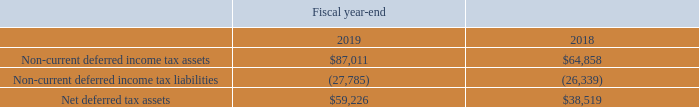The net deferred tax asset is classified on the consolidated balance sheets as follows (in thousands):
We have various tax attribute carryforwards which include the following:
• Foreign federal and local gross net operating loss carryforwards are $61.6 million, of which $47.0 million have no expiration date and $14.6 million have various expiration dates beginning in fiscal 2020. Among the total of $61.6 million foreign net operating loss carryforwards, a valuation allowance of $31.7 million has been provided for certain jurisdictions since the recovery of the carryforwards is uncertain. U.S. federal and certain state gross net operating loss carryforwards are $14.0 million and $30.7 million, respectively, which were acquired from our acquisitions. A full valuation allowance against certain other state net operating losses of $30.7 million has been recorded. California gross net operating loss carryforwards are $2.8 million and are scheduled to expire beginning in fiscal 2032.
• U.S. federal R&D credit carryforwards of $35.4 million are scheduled to expire beginning in fiscal 2025. California R&D credit carryforwards of $32.2 million have no expiration date. A total of $27.1 million valuation allowance, before U.S. federal benefit, has been recorded against California R&D credit carryforwards of $32.2 million since the recovery of the carryforwards is uncertain. Other states R&D credit carryforwards of $3.9 million are scheduled to expire beginning in fiscal 2020. A valuation allowance totaling $2.7 million, before U.S. federal benefit, has been recorded against certain state R&D credit carryforwards of $3.9 million since the recovery of the carryforwards is uncertain.
• U.S. federal foreign tax credit carryforwards of $51.9 million are scheduled to expire beginning in fiscal 2022.
What was the Net deferred tax assets in 2019?
Answer scale should be: thousand. $59,226. What was the  Non-current deferred income tax assets  in 2018?
Answer scale should be: thousand. $64,858. In which years were Net deferred tax assets calculated? 2019, 2018. In which year was the amount of Net deferred tax assets larger? 59,226>38,519
Answer: 2019. What was the change in Net deferred tax assets from 2018 to 2019?
Answer scale should be: thousand. 59,226-38,519
Answer: 20707. What was the percentage change in Net deferred tax assets from 2018 to 2019?
Answer scale should be: percent. (59,226-38,519)/38,519
Answer: 53.76. 